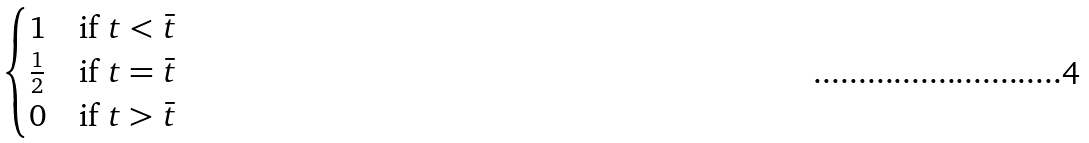<formula> <loc_0><loc_0><loc_500><loc_500>\begin{cases} 1 & \text {if } t < \bar { t } \\ \frac { 1 } { 2 } & \text {if } t = \bar { t } \\ 0 & \text {if } t > \bar { t } \end{cases}</formula> 